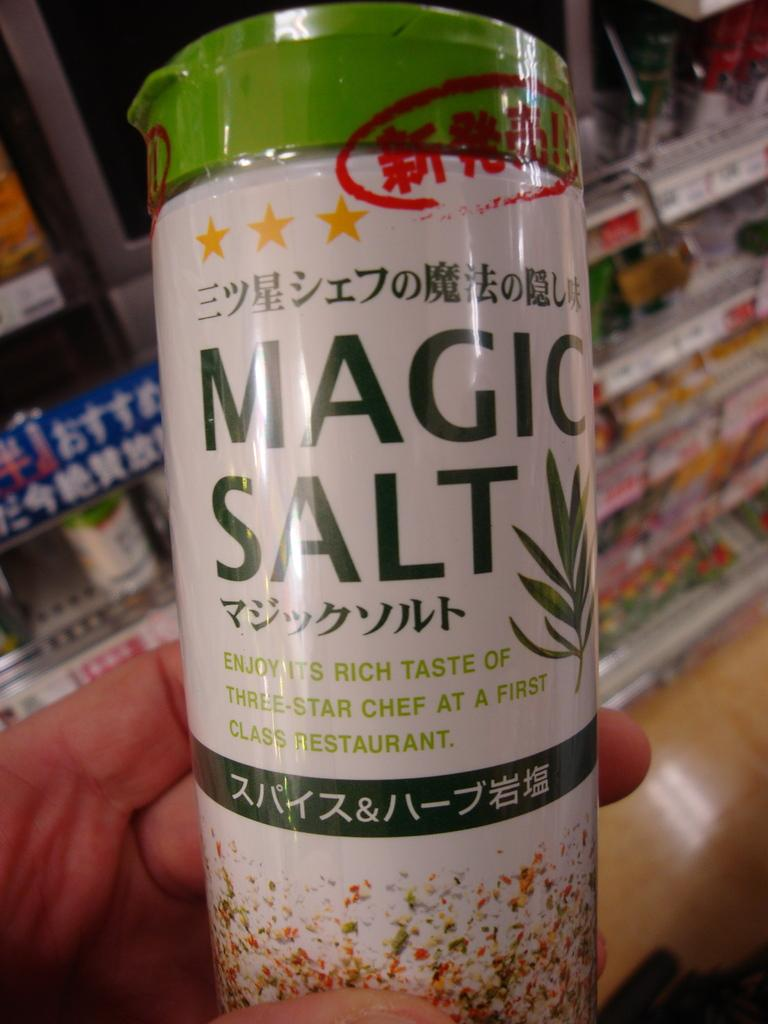<image>
Create a compact narrative representing the image presented. A can of cooking salt that is mostly in Japanese 